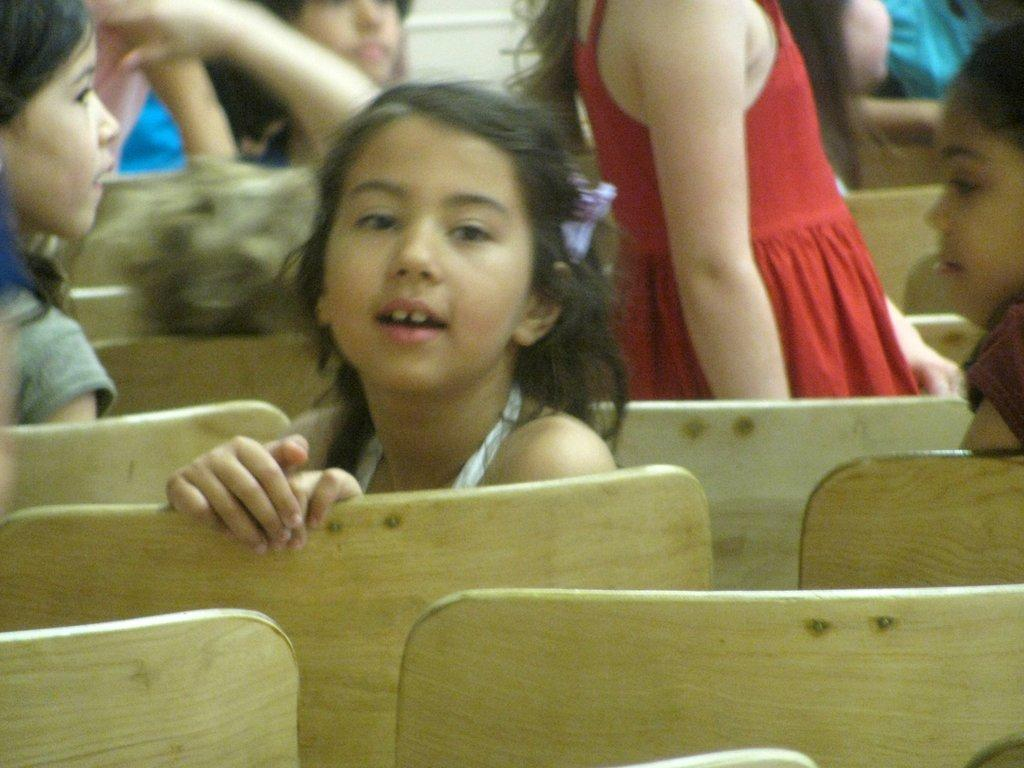What can be seen in the image? There are kids in the image. Can you describe the positions of the kids in the image? Some kids are sitting, while others are standing. What is the arrangement of the chairs in the image? There are empty chairs in the front of the image. What type of shape can be seen on the deer's antlers in the image? There are no deer or antlers present in the image. What sound do the bells make in the image? There are no bells present in the image. 